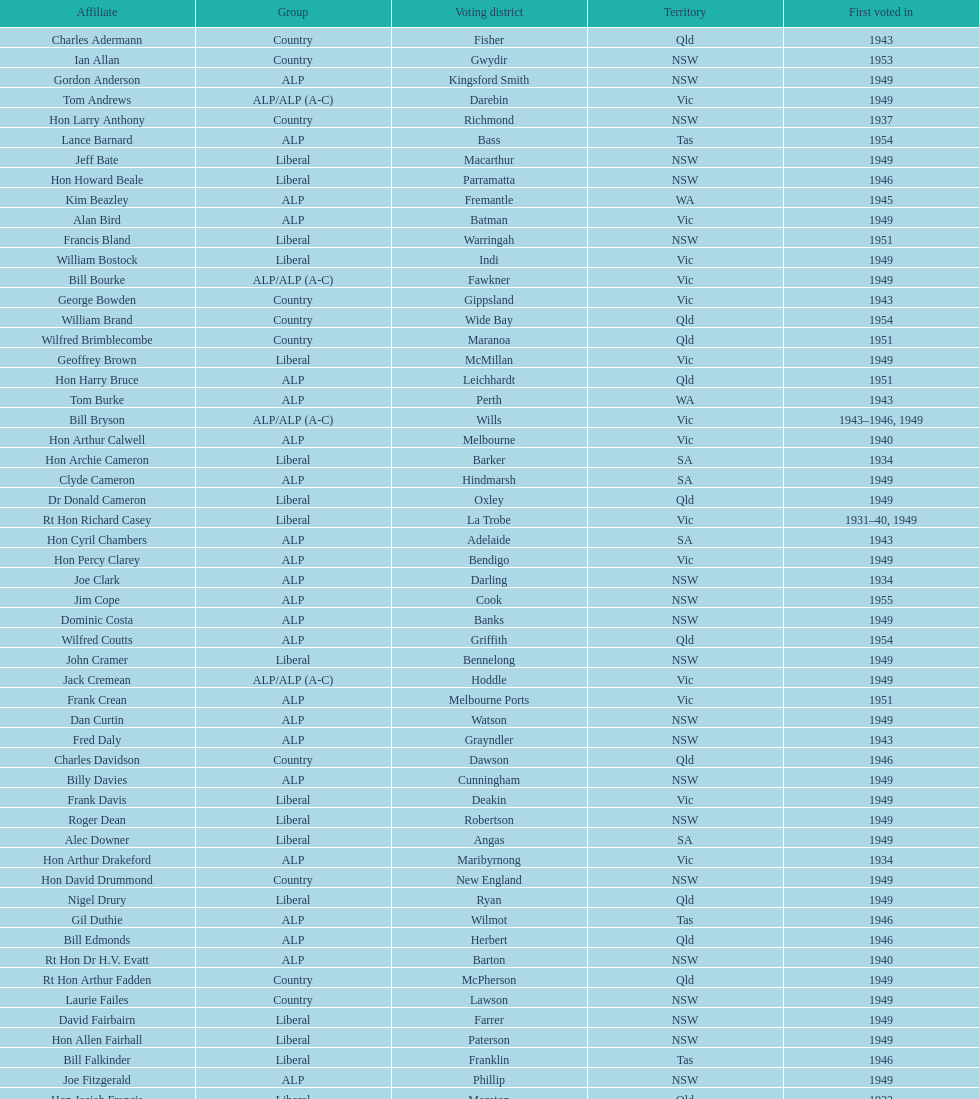Who was the first member to be elected? Charles Adermann. 